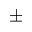Convert formula to latex. <formula><loc_0><loc_0><loc_500><loc_500>\pm</formula> 